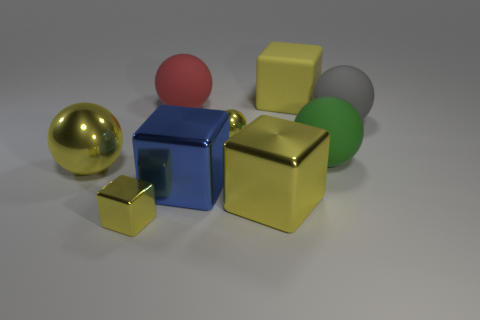How is the lighting affecting the appearance of the objects? The lighting in the image seems soft and diffused, creating gentle shadows that help to emphasize the shapes and contours of the objects. The reflective surfaces of the metallic gold sphere and the blue cube are picking up highlights that give them a three-dimensional quality and the sense of being in a tangible space. 